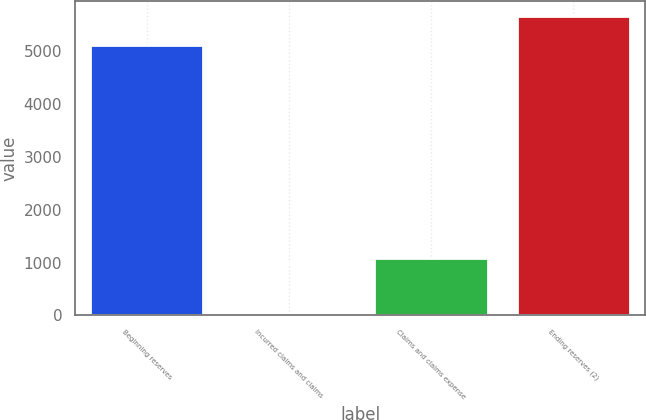Convert chart. <chart><loc_0><loc_0><loc_500><loc_500><bar_chart><fcel>Beginning reserves<fcel>Incurred claims and claims<fcel>Claims and claims expense<fcel>Ending reserves (2)<nl><fcel>5121<fcel>8<fcel>1095<fcel>5664.5<nl></chart> 